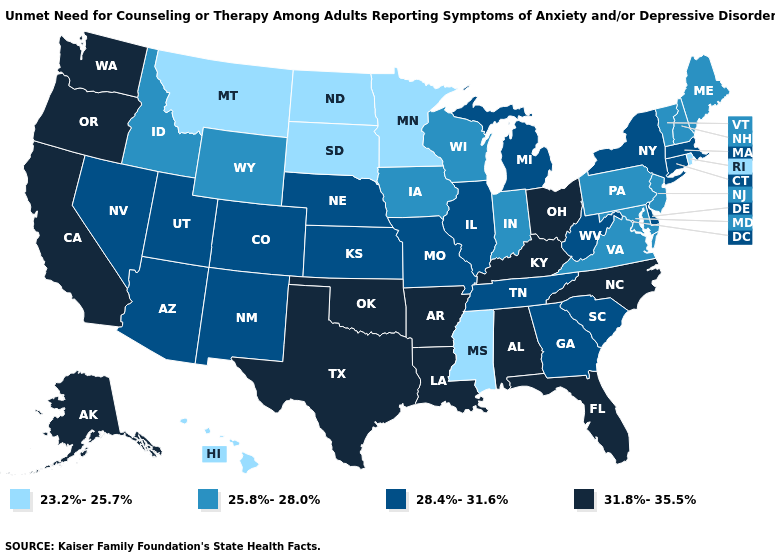How many symbols are there in the legend?
Be succinct. 4. Name the states that have a value in the range 25.8%-28.0%?
Short answer required. Idaho, Indiana, Iowa, Maine, Maryland, New Hampshire, New Jersey, Pennsylvania, Vermont, Virginia, Wisconsin, Wyoming. Is the legend a continuous bar?
Short answer required. No. Name the states that have a value in the range 23.2%-25.7%?
Write a very short answer. Hawaii, Minnesota, Mississippi, Montana, North Dakota, Rhode Island, South Dakota. Name the states that have a value in the range 23.2%-25.7%?
Concise answer only. Hawaii, Minnesota, Mississippi, Montana, North Dakota, Rhode Island, South Dakota. Name the states that have a value in the range 28.4%-31.6%?
Answer briefly. Arizona, Colorado, Connecticut, Delaware, Georgia, Illinois, Kansas, Massachusetts, Michigan, Missouri, Nebraska, Nevada, New Mexico, New York, South Carolina, Tennessee, Utah, West Virginia. Does Alabama have the highest value in the USA?
Answer briefly. Yes. What is the value of Missouri?
Short answer required. 28.4%-31.6%. Name the states that have a value in the range 31.8%-35.5%?
Be succinct. Alabama, Alaska, Arkansas, California, Florida, Kentucky, Louisiana, North Carolina, Ohio, Oklahoma, Oregon, Texas, Washington. How many symbols are there in the legend?
Answer briefly. 4. What is the value of Maine?
Concise answer only. 25.8%-28.0%. Among the states that border Utah , does Wyoming have the highest value?
Give a very brief answer. No. Does the map have missing data?
Quick response, please. No. Among the states that border Nevada , does Utah have the lowest value?
Answer briefly. No. 